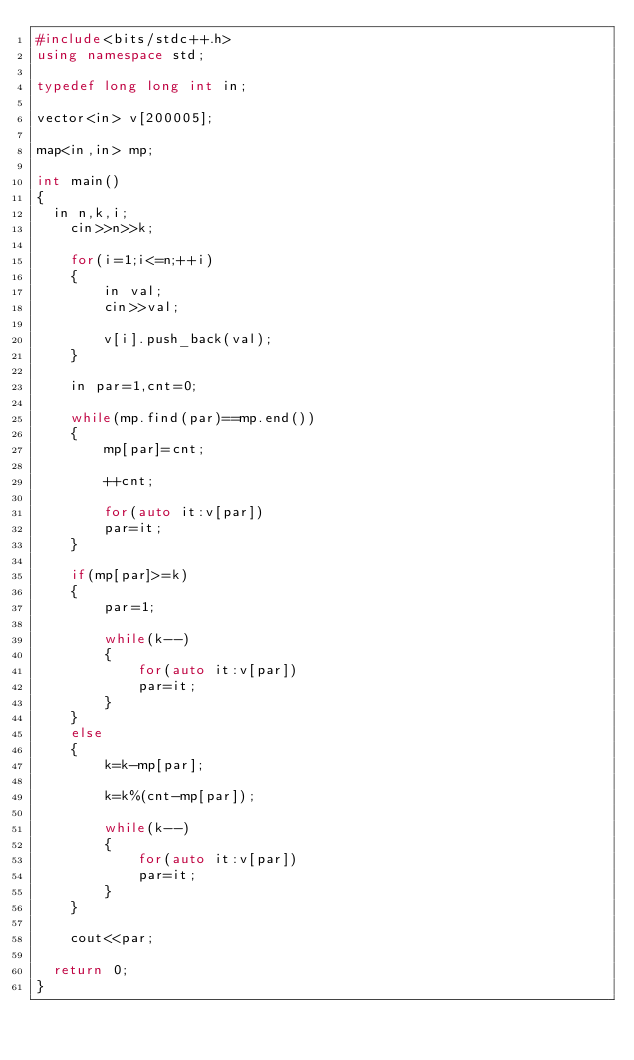Convert code to text. <code><loc_0><loc_0><loc_500><loc_500><_C++_>#include<bits/stdc++.h>
using namespace std;

typedef long long int in;

vector<in> v[200005];

map<in,in> mp;

int main() 
{
	in n,k,i;
    cin>>n>>k;

    for(i=1;i<=n;++i)
    {
        in val;
        cin>>val;

        v[i].push_back(val);
    }

    in par=1,cnt=0;

    while(mp.find(par)==mp.end())
    {
        mp[par]=cnt;

        ++cnt;

        for(auto it:v[par])
        par=it;
    }
    
    if(mp[par]>=k)
    {
        par=1;

        while(k--)
        {
            for(auto it:v[par])
            par=it;
        }
    }
    else
    {
        k=k-mp[par];

        k=k%(cnt-mp[par]);

        while(k--)
        {
            for(auto it:v[par])
            par=it;
        }
    }

    cout<<par;

	return 0;
}



</code> 